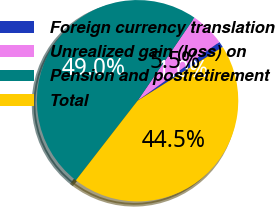Convert chart to OTSL. <chart><loc_0><loc_0><loc_500><loc_500><pie_chart><fcel>Foreign currency translation<fcel>Unrealized gain (loss) on<fcel>Pension and postretirement<fcel>Total<nl><fcel>0.96%<fcel>5.54%<fcel>49.04%<fcel>44.46%<nl></chart> 